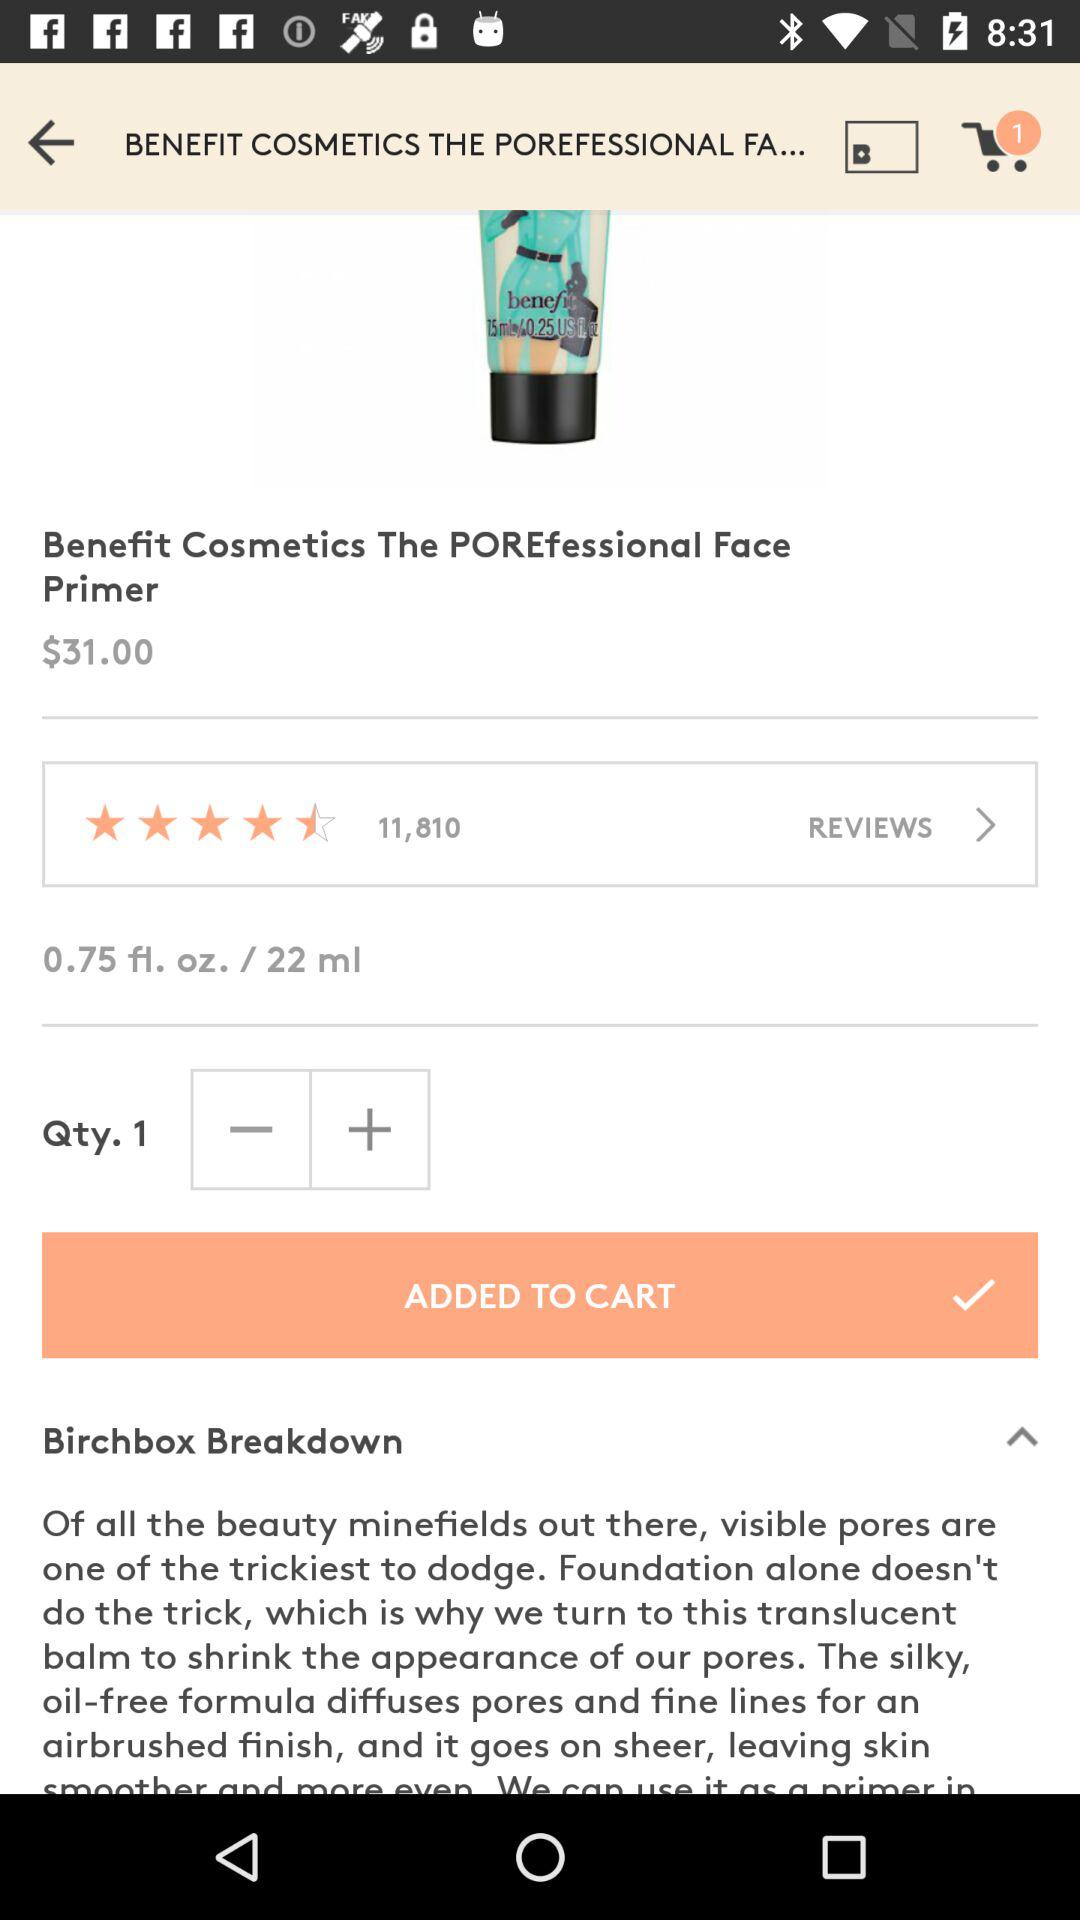How many items are added to the cart? There is 1 item added to the cart. 